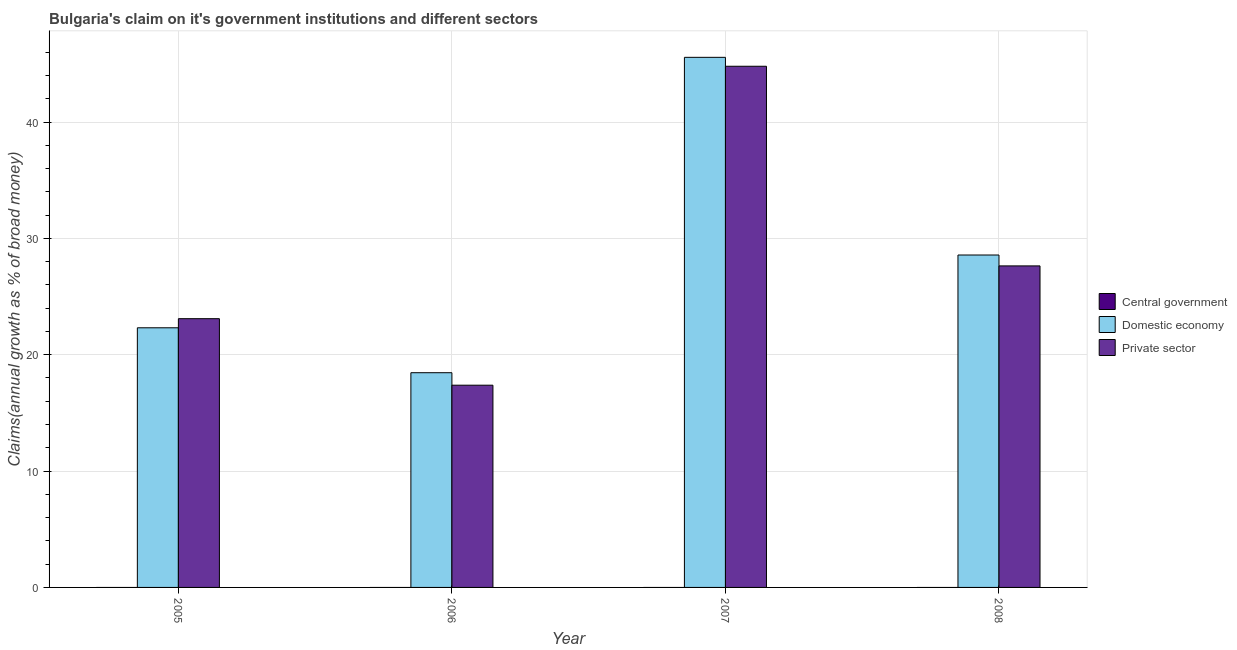Are the number of bars per tick equal to the number of legend labels?
Offer a very short reply. No. Are the number of bars on each tick of the X-axis equal?
Make the answer very short. Yes. In how many cases, is the number of bars for a given year not equal to the number of legend labels?
Ensure brevity in your answer.  4. What is the percentage of claim on the private sector in 2006?
Your answer should be very brief. 17.38. Across all years, what is the maximum percentage of claim on the domestic economy?
Your response must be concise. 45.56. Across all years, what is the minimum percentage of claim on the private sector?
Give a very brief answer. 17.38. What is the total percentage of claim on the domestic economy in the graph?
Provide a succinct answer. 114.9. What is the difference between the percentage of claim on the domestic economy in 2007 and that in 2008?
Ensure brevity in your answer.  16.99. What is the difference between the percentage of claim on the central government in 2007 and the percentage of claim on the domestic economy in 2005?
Your response must be concise. 0. What is the average percentage of claim on the central government per year?
Your response must be concise. 0. In the year 2006, what is the difference between the percentage of claim on the domestic economy and percentage of claim on the central government?
Offer a terse response. 0. What is the ratio of the percentage of claim on the private sector in 2005 to that in 2007?
Provide a short and direct response. 0.52. Is the difference between the percentage of claim on the private sector in 2005 and 2006 greater than the difference between the percentage of claim on the domestic economy in 2005 and 2006?
Offer a terse response. No. What is the difference between the highest and the second highest percentage of claim on the private sector?
Give a very brief answer. 17.16. What is the difference between the highest and the lowest percentage of claim on the domestic economy?
Your response must be concise. 27.11. Is the sum of the percentage of claim on the domestic economy in 2007 and 2008 greater than the maximum percentage of claim on the central government across all years?
Your response must be concise. Yes. Are all the bars in the graph horizontal?
Your response must be concise. No. How many years are there in the graph?
Give a very brief answer. 4. Does the graph contain grids?
Your answer should be very brief. Yes. How are the legend labels stacked?
Offer a very short reply. Vertical. What is the title of the graph?
Your response must be concise. Bulgaria's claim on it's government institutions and different sectors. Does "Social Protection" appear as one of the legend labels in the graph?
Your answer should be compact. No. What is the label or title of the X-axis?
Offer a terse response. Year. What is the label or title of the Y-axis?
Your answer should be compact. Claims(annual growth as % of broad money). What is the Claims(annual growth as % of broad money) in Domestic economy in 2005?
Offer a very short reply. 22.32. What is the Claims(annual growth as % of broad money) in Private sector in 2005?
Your response must be concise. 23.1. What is the Claims(annual growth as % of broad money) of Central government in 2006?
Offer a very short reply. 0. What is the Claims(annual growth as % of broad money) in Domestic economy in 2006?
Offer a terse response. 18.45. What is the Claims(annual growth as % of broad money) of Private sector in 2006?
Provide a short and direct response. 17.38. What is the Claims(annual growth as % of broad money) of Central government in 2007?
Your answer should be compact. 0. What is the Claims(annual growth as % of broad money) of Domestic economy in 2007?
Your answer should be compact. 45.56. What is the Claims(annual growth as % of broad money) in Private sector in 2007?
Provide a succinct answer. 44.79. What is the Claims(annual growth as % of broad money) in Central government in 2008?
Keep it short and to the point. 0. What is the Claims(annual growth as % of broad money) in Domestic economy in 2008?
Your answer should be compact. 28.57. What is the Claims(annual growth as % of broad money) in Private sector in 2008?
Keep it short and to the point. 27.63. Across all years, what is the maximum Claims(annual growth as % of broad money) of Domestic economy?
Give a very brief answer. 45.56. Across all years, what is the maximum Claims(annual growth as % of broad money) of Private sector?
Your response must be concise. 44.79. Across all years, what is the minimum Claims(annual growth as % of broad money) of Domestic economy?
Provide a succinct answer. 18.45. Across all years, what is the minimum Claims(annual growth as % of broad money) in Private sector?
Ensure brevity in your answer.  17.38. What is the total Claims(annual growth as % of broad money) in Central government in the graph?
Offer a very short reply. 0. What is the total Claims(annual growth as % of broad money) in Domestic economy in the graph?
Make the answer very short. 114.9. What is the total Claims(annual growth as % of broad money) in Private sector in the graph?
Give a very brief answer. 112.91. What is the difference between the Claims(annual growth as % of broad money) in Domestic economy in 2005 and that in 2006?
Ensure brevity in your answer.  3.86. What is the difference between the Claims(annual growth as % of broad money) in Private sector in 2005 and that in 2006?
Provide a succinct answer. 5.72. What is the difference between the Claims(annual growth as % of broad money) of Domestic economy in 2005 and that in 2007?
Your response must be concise. -23.24. What is the difference between the Claims(annual growth as % of broad money) of Private sector in 2005 and that in 2007?
Give a very brief answer. -21.69. What is the difference between the Claims(annual growth as % of broad money) in Domestic economy in 2005 and that in 2008?
Your answer should be very brief. -6.26. What is the difference between the Claims(annual growth as % of broad money) of Private sector in 2005 and that in 2008?
Provide a succinct answer. -4.54. What is the difference between the Claims(annual growth as % of broad money) of Domestic economy in 2006 and that in 2007?
Offer a terse response. -27.11. What is the difference between the Claims(annual growth as % of broad money) in Private sector in 2006 and that in 2007?
Keep it short and to the point. -27.41. What is the difference between the Claims(annual growth as % of broad money) of Domestic economy in 2006 and that in 2008?
Ensure brevity in your answer.  -10.12. What is the difference between the Claims(annual growth as % of broad money) of Private sector in 2006 and that in 2008?
Provide a short and direct response. -10.25. What is the difference between the Claims(annual growth as % of broad money) in Domestic economy in 2007 and that in 2008?
Your response must be concise. 16.99. What is the difference between the Claims(annual growth as % of broad money) in Private sector in 2007 and that in 2008?
Your answer should be compact. 17.16. What is the difference between the Claims(annual growth as % of broad money) in Domestic economy in 2005 and the Claims(annual growth as % of broad money) in Private sector in 2006?
Offer a very short reply. 4.93. What is the difference between the Claims(annual growth as % of broad money) in Domestic economy in 2005 and the Claims(annual growth as % of broad money) in Private sector in 2007?
Offer a terse response. -22.48. What is the difference between the Claims(annual growth as % of broad money) of Domestic economy in 2005 and the Claims(annual growth as % of broad money) of Private sector in 2008?
Provide a short and direct response. -5.32. What is the difference between the Claims(annual growth as % of broad money) of Domestic economy in 2006 and the Claims(annual growth as % of broad money) of Private sector in 2007?
Provide a short and direct response. -26.34. What is the difference between the Claims(annual growth as % of broad money) of Domestic economy in 2006 and the Claims(annual growth as % of broad money) of Private sector in 2008?
Make the answer very short. -9.18. What is the difference between the Claims(annual growth as % of broad money) of Domestic economy in 2007 and the Claims(annual growth as % of broad money) of Private sector in 2008?
Your answer should be compact. 17.93. What is the average Claims(annual growth as % of broad money) of Domestic economy per year?
Offer a very short reply. 28.72. What is the average Claims(annual growth as % of broad money) of Private sector per year?
Your answer should be very brief. 28.23. In the year 2005, what is the difference between the Claims(annual growth as % of broad money) of Domestic economy and Claims(annual growth as % of broad money) of Private sector?
Your response must be concise. -0.78. In the year 2006, what is the difference between the Claims(annual growth as % of broad money) of Domestic economy and Claims(annual growth as % of broad money) of Private sector?
Provide a succinct answer. 1.07. In the year 2007, what is the difference between the Claims(annual growth as % of broad money) in Domestic economy and Claims(annual growth as % of broad money) in Private sector?
Provide a succinct answer. 0.77. In the year 2008, what is the difference between the Claims(annual growth as % of broad money) of Domestic economy and Claims(annual growth as % of broad money) of Private sector?
Your response must be concise. 0.94. What is the ratio of the Claims(annual growth as % of broad money) of Domestic economy in 2005 to that in 2006?
Provide a short and direct response. 1.21. What is the ratio of the Claims(annual growth as % of broad money) of Private sector in 2005 to that in 2006?
Your answer should be very brief. 1.33. What is the ratio of the Claims(annual growth as % of broad money) in Domestic economy in 2005 to that in 2007?
Make the answer very short. 0.49. What is the ratio of the Claims(annual growth as % of broad money) of Private sector in 2005 to that in 2007?
Your response must be concise. 0.52. What is the ratio of the Claims(annual growth as % of broad money) in Domestic economy in 2005 to that in 2008?
Your response must be concise. 0.78. What is the ratio of the Claims(annual growth as % of broad money) in Private sector in 2005 to that in 2008?
Provide a succinct answer. 0.84. What is the ratio of the Claims(annual growth as % of broad money) of Domestic economy in 2006 to that in 2007?
Give a very brief answer. 0.41. What is the ratio of the Claims(annual growth as % of broad money) in Private sector in 2006 to that in 2007?
Ensure brevity in your answer.  0.39. What is the ratio of the Claims(annual growth as % of broad money) of Domestic economy in 2006 to that in 2008?
Make the answer very short. 0.65. What is the ratio of the Claims(annual growth as % of broad money) in Private sector in 2006 to that in 2008?
Ensure brevity in your answer.  0.63. What is the ratio of the Claims(annual growth as % of broad money) of Domestic economy in 2007 to that in 2008?
Ensure brevity in your answer.  1.59. What is the ratio of the Claims(annual growth as % of broad money) of Private sector in 2007 to that in 2008?
Your answer should be very brief. 1.62. What is the difference between the highest and the second highest Claims(annual growth as % of broad money) in Domestic economy?
Offer a very short reply. 16.99. What is the difference between the highest and the second highest Claims(annual growth as % of broad money) in Private sector?
Provide a succinct answer. 17.16. What is the difference between the highest and the lowest Claims(annual growth as % of broad money) in Domestic economy?
Your answer should be very brief. 27.11. What is the difference between the highest and the lowest Claims(annual growth as % of broad money) in Private sector?
Your response must be concise. 27.41. 